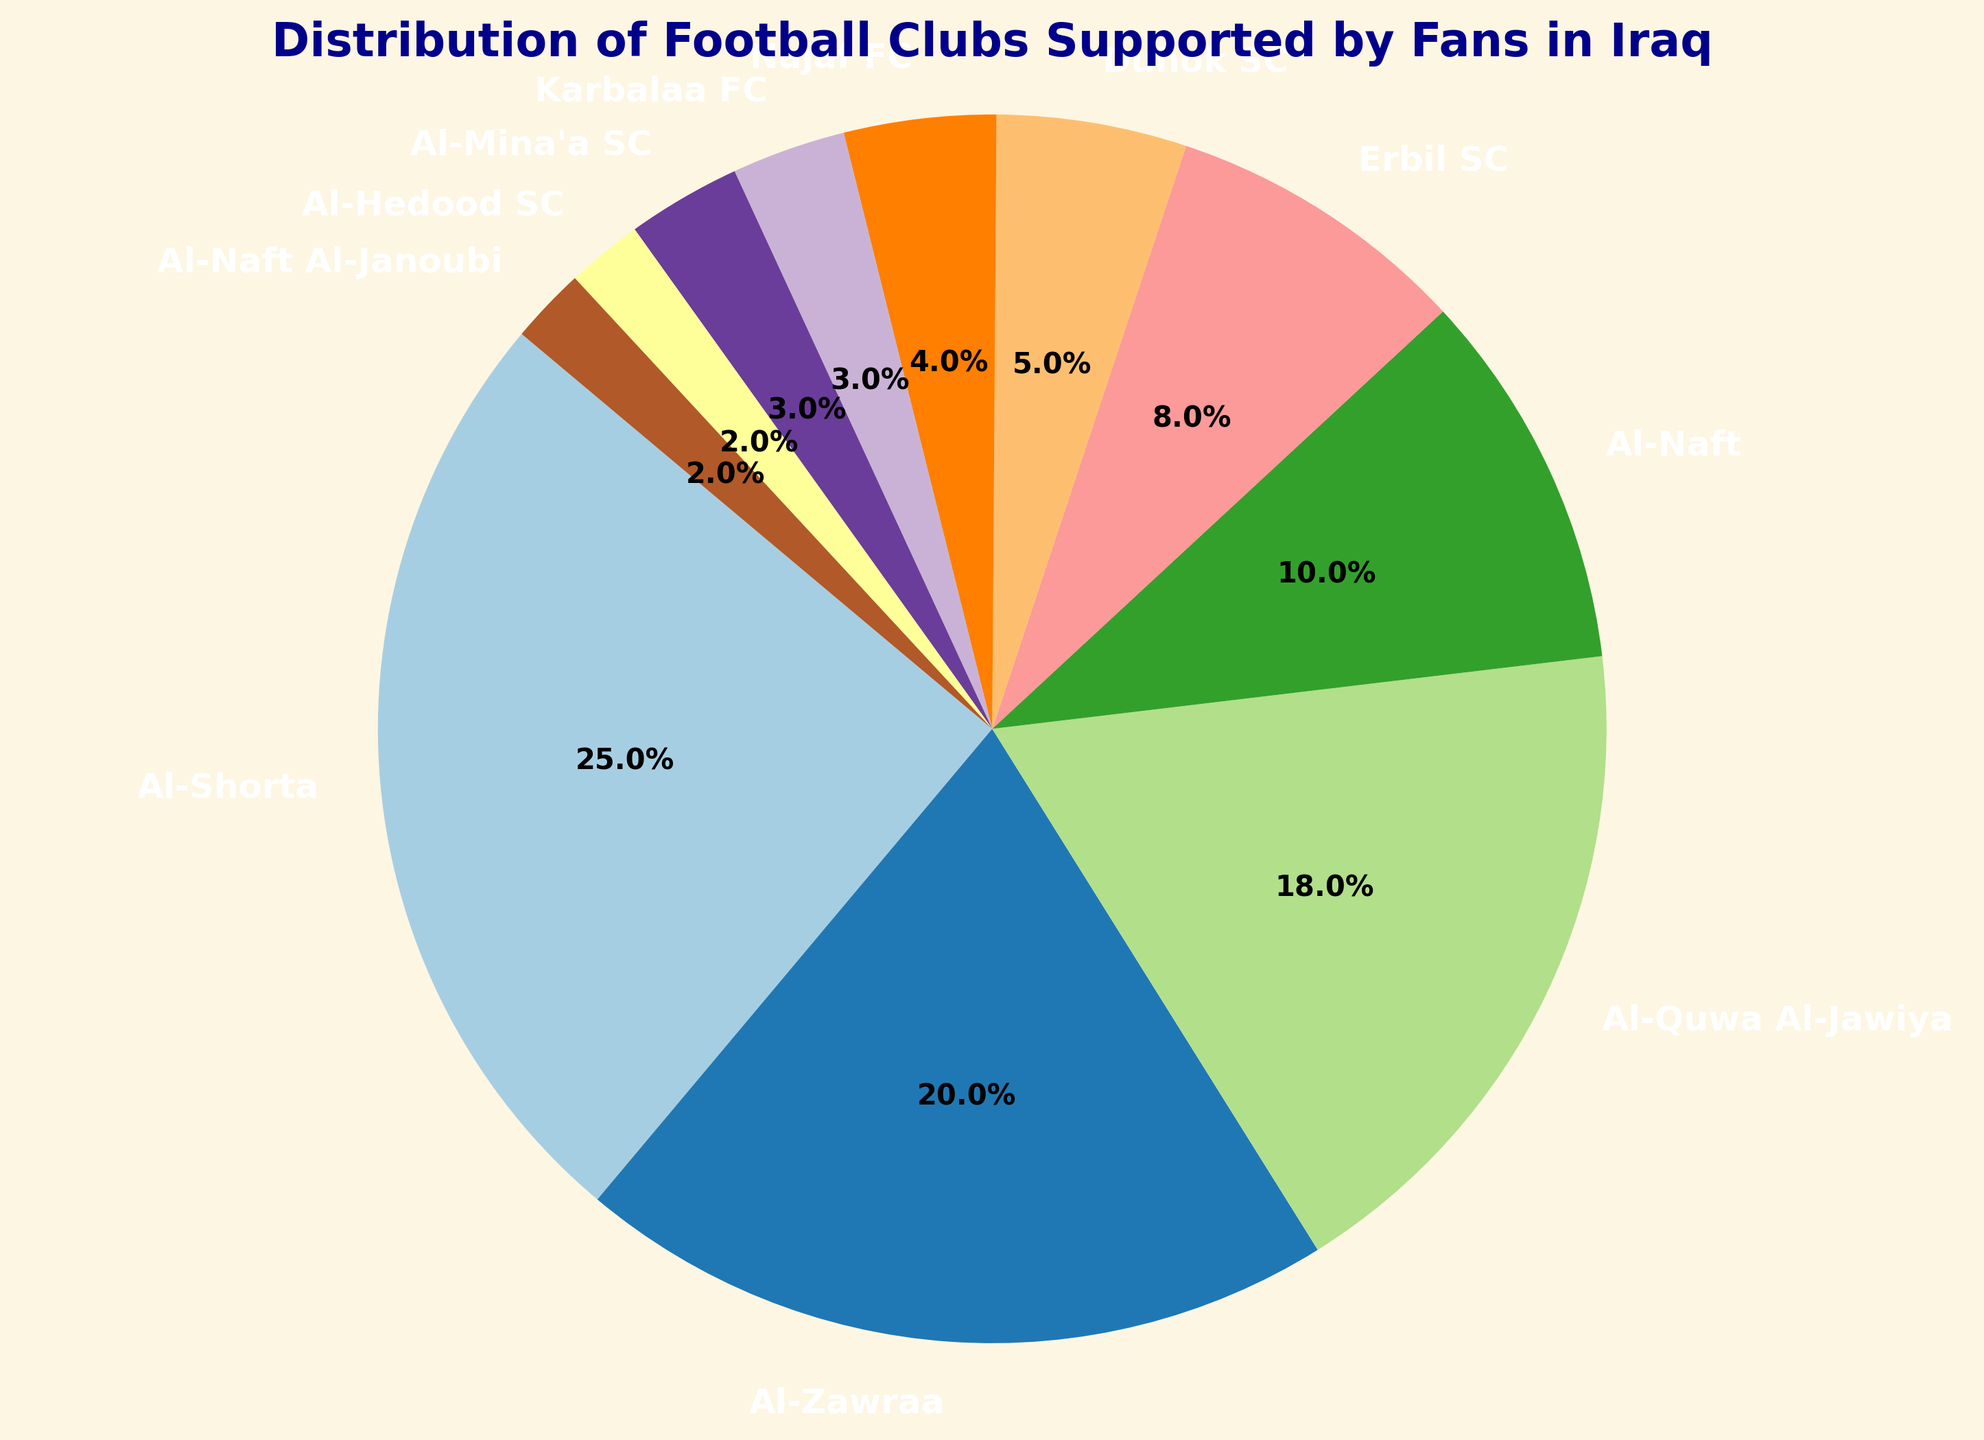What's the most supported football club in Iraq? The pie chart shows the distribution of football clubs supported by fans in Iraq. The club with the highest percentage of support is Al-Shorta.
Answer: Al-Shorta Which club has a smaller support percentage than Al-Zawraa but larger than Duhok SC? From the chart, Al-Zawraa has a 20% support rate, and Duhok SC has a 5% support rate. Al-Quwa Al-Jawiya fits this criteria with an 18% support rate.
Answer: Al-Quwa Al-Jawiya What's the combined support percentage of Erbil SC and Al-Naft? Erbil SC has 8% and Al-Naft has 10% support. Adding these together: 8% + 10% = 18%
Answer: 18% How does the support for Al-Shorta compare to Najaf FC? Al-Shorta has 25% support and Najaf FC has 4% support. Al-Shorta's support is significantly higher.
Answer: Al-Shorta has much higher support Which club has the least support percentage? The pie chart indicates that Al-Hedood SC and Al-Naft Al-Janoubi both have 2% support, which is the lowest.
Answer: Al-Hedood SC and Al-Naft Al-Janoubi How does the support for Karbalaa FC compare to Al-Mina'a SC? Both Karbalaa FC and Al-Mina'a SC have a 3% support rate as shown in the pie chart.
Answer: Equal What's the total support percentage for clubs with less than 10% support each? Clubs with less than 10% support are Erbil SC (8%), Duhok SC (5%), Najaf FC (4%), Karbalaa FC (3%), Al-Mina'a SC (3%), Al-Hedood SC (2%), and Al-Naft Al-Janoubi (2%). Adding these, we get: 8% + 5% + 4% + 3% + 3% + 2% + 2% = 27%
Answer: 27% Which club has almost double the support percentage of Al-Naft? Al-Naft has 10% support. Al-Zawraa has 20% support, which is double that of Al-Naft.
Answer: Al-Zawraa 